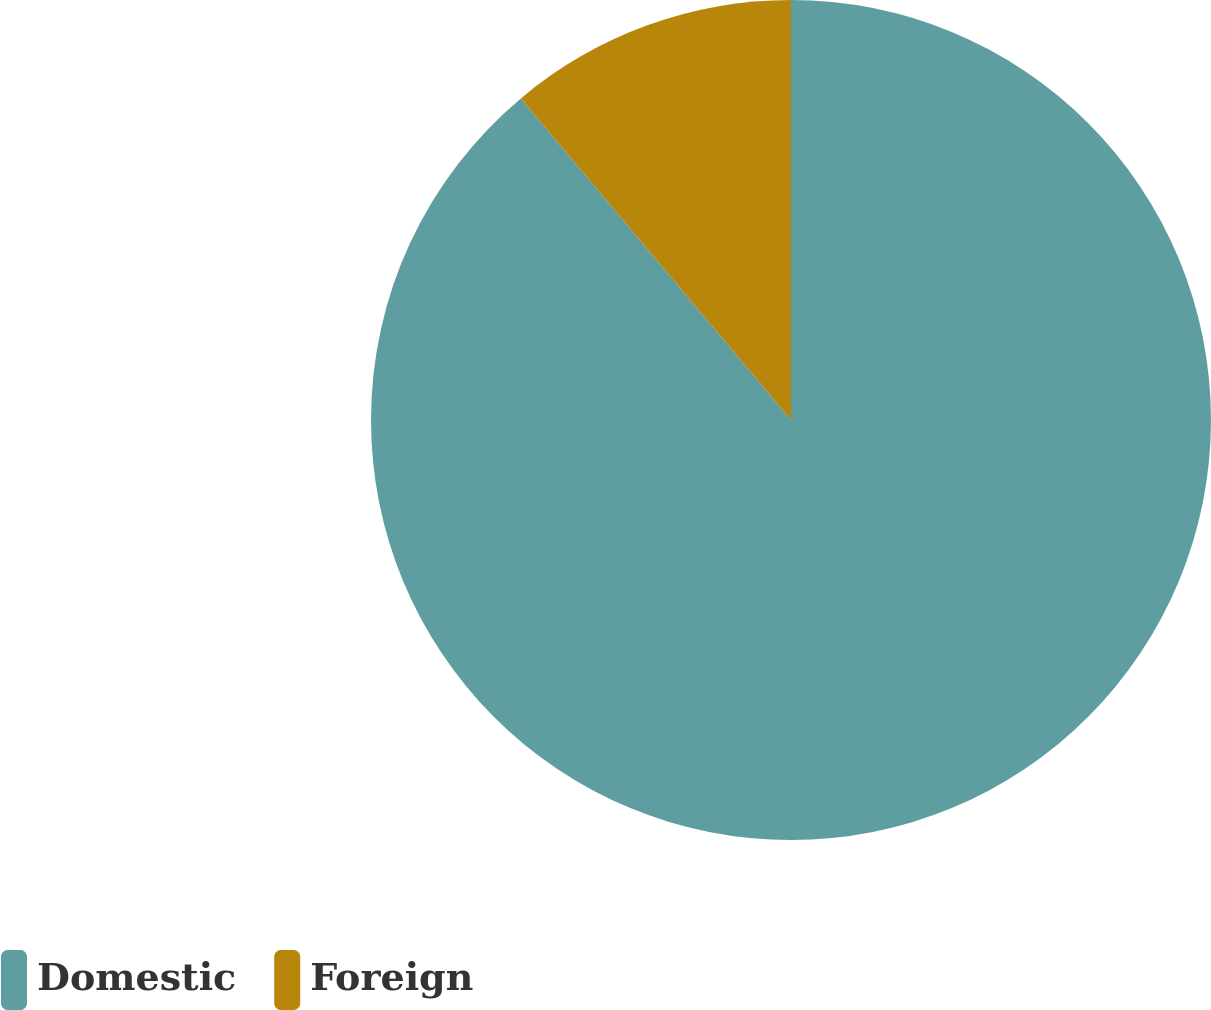Convert chart. <chart><loc_0><loc_0><loc_500><loc_500><pie_chart><fcel>Domestic<fcel>Foreign<nl><fcel>88.88%<fcel>11.12%<nl></chart> 